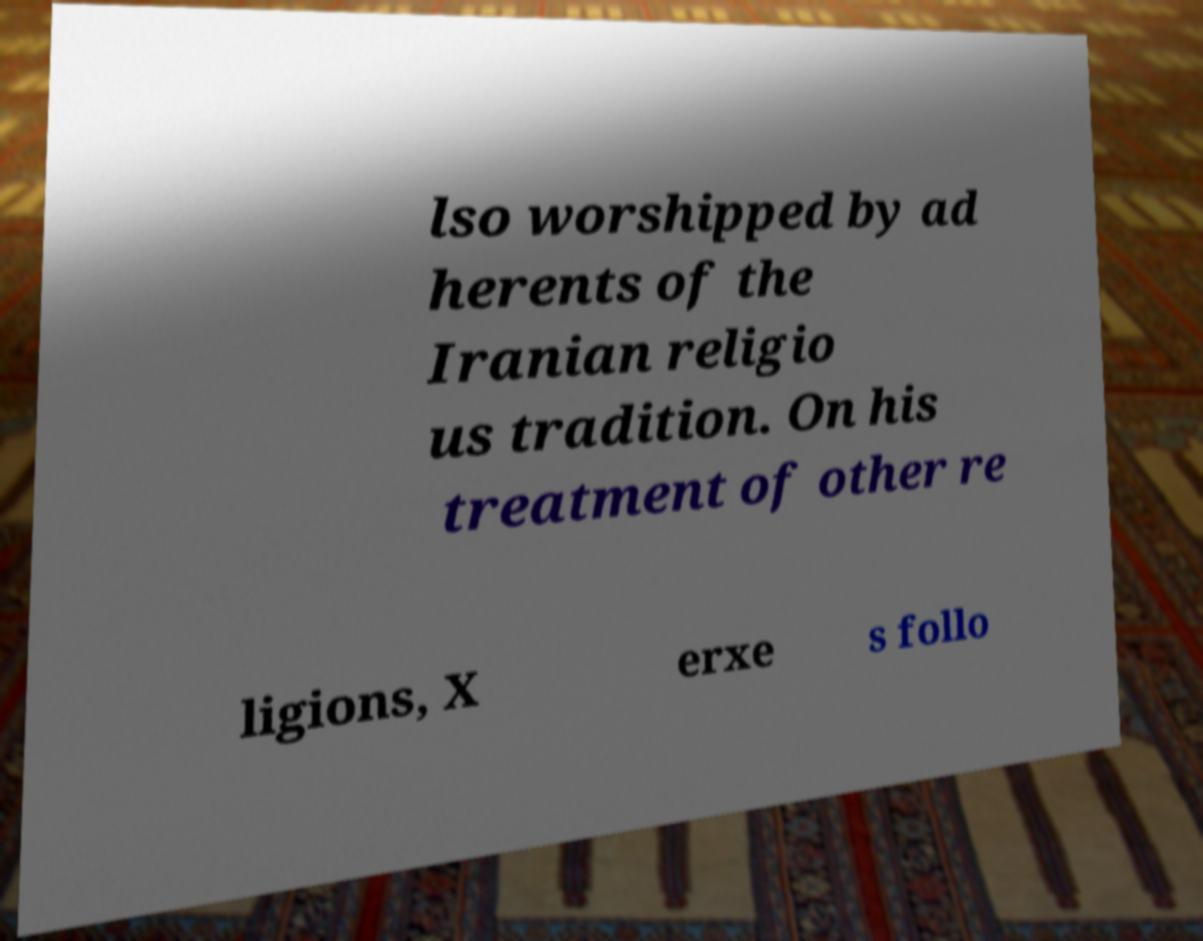Can you read and provide the text displayed in the image?This photo seems to have some interesting text. Can you extract and type it out for me? lso worshipped by ad herents of the Iranian religio us tradition. On his treatment of other re ligions, X erxe s follo 